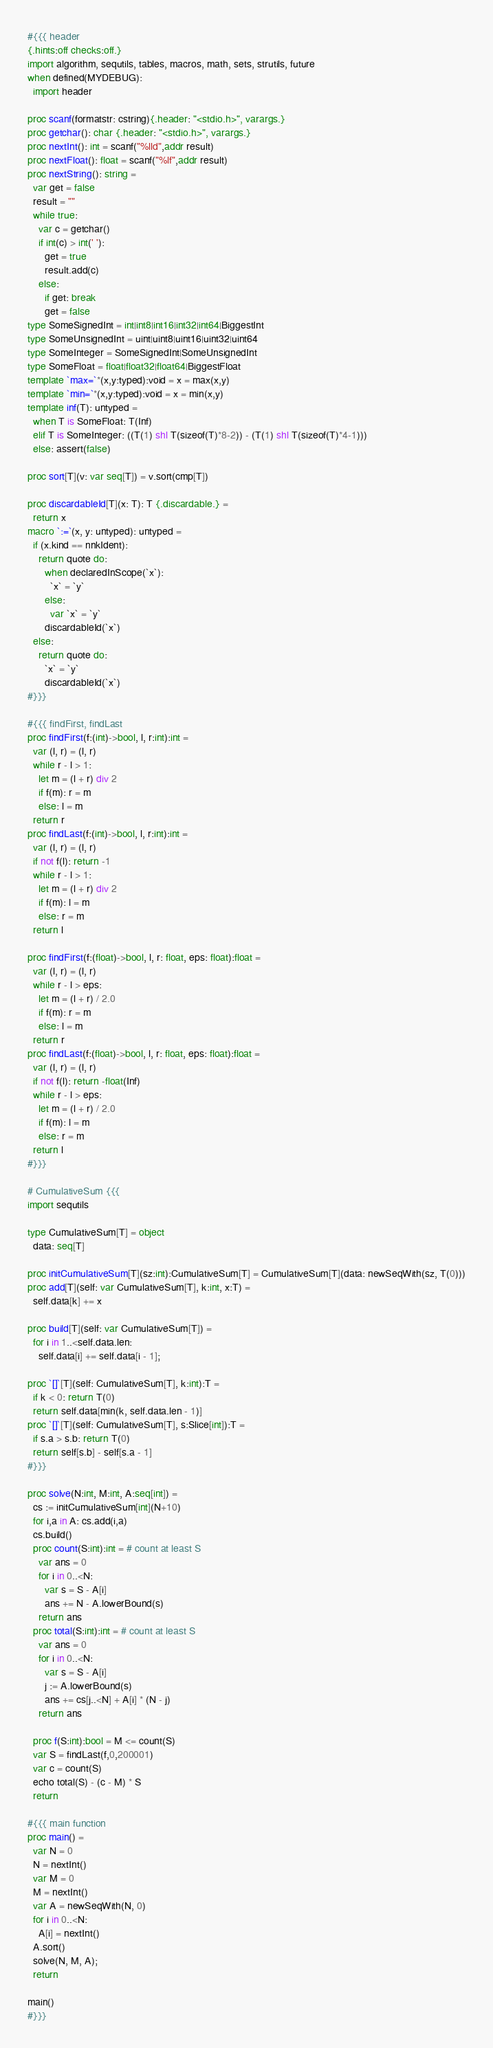<code> <loc_0><loc_0><loc_500><loc_500><_Nim_>#{{{ header
{.hints:off checks:off.}
import algorithm, sequtils, tables, macros, math, sets, strutils, future
when defined(MYDEBUG):
  import header

proc scanf(formatstr: cstring){.header: "<stdio.h>", varargs.}
proc getchar(): char {.header: "<stdio.h>", varargs.}
proc nextInt(): int = scanf("%lld",addr result)
proc nextFloat(): float = scanf("%lf",addr result)
proc nextString(): string =
  var get = false
  result = ""
  while true:
    var c = getchar()
    if int(c) > int(' '):
      get = true
      result.add(c)
    else:
      if get: break
      get = false
type SomeSignedInt = int|int8|int16|int32|int64|BiggestInt
type SomeUnsignedInt = uint|uint8|uint16|uint32|uint64
type SomeInteger = SomeSignedInt|SomeUnsignedInt
type SomeFloat = float|float32|float64|BiggestFloat
template `max=`*(x,y:typed):void = x = max(x,y)
template `min=`*(x,y:typed):void = x = min(x,y)
template inf(T): untyped = 
  when T is SomeFloat: T(Inf)
  elif T is SomeInteger: ((T(1) shl T(sizeof(T)*8-2)) - (T(1) shl T(sizeof(T)*4-1)))
  else: assert(false)

proc sort[T](v: var seq[T]) = v.sort(cmp[T])

proc discardableId[T](x: T): T {.discardable.} =
  return x
macro `:=`(x, y: untyped): untyped =
  if (x.kind == nnkIdent):
    return quote do:
      when declaredInScope(`x`):
        `x` = `y`
      else:
        var `x` = `y`
      discardableId(`x`)
  else:
    return quote do:
      `x` = `y`
      discardableId(`x`)
#}}}

#{{{ findFirst, findLast
proc findFirst(f:(int)->bool, l, r:int):int =
  var (l, r) = (l, r)
  while r - l > 1:
    let m = (l + r) div 2
    if f(m): r = m
    else: l = m
  return r
proc findLast(f:(int)->bool, l, r:int):int =
  var (l, r) = (l, r)
  if not f(l): return -1
  while r - l > 1:
    let m = (l + r) div 2
    if f(m): l = m
    else: r = m
  return l

proc findFirst(f:(float)->bool, l, r: float, eps: float):float =
  var (l, r) = (l, r)
  while r - l > eps:
    let m = (l + r) / 2.0
    if f(m): r = m
    else: l = m
  return r
proc findLast(f:(float)->bool, l, r: float, eps: float):float =
  var (l, r) = (l, r)
  if not f(l): return -float(Inf)
  while r - l > eps:
    let m = (l + r) / 2.0
    if f(m): l = m
    else: r = m
  return l
#}}}

# CumulativeSum {{{
import sequtils

type CumulativeSum[T] = object
  data: seq[T]

proc initCumulativeSum[T](sz:int):CumulativeSum[T] = CumulativeSum[T](data: newSeqWith(sz, T(0)))
proc add[T](self: var CumulativeSum[T], k:int, x:T) =
  self.data[k] += x

proc build[T](self: var CumulativeSum[T]) =
  for i in 1..<self.data.len:
    self.data[i] += self.data[i - 1];

proc `[]`[T](self: CumulativeSum[T], k:int):T =
  if k < 0: return T(0)
  return self.data[min(k, self.data.len - 1)]
proc `[]`[T](self: CumulativeSum[T], s:Slice[int]):T =
  if s.a > s.b: return T(0)
  return self[s.b] - self[s.a - 1]
#}}}

proc solve(N:int, M:int, A:seq[int]) =
  cs := initCumulativeSum[int](N+10)
  for i,a in A: cs.add(i,a)
  cs.build()
  proc count(S:int):int = # count at least S
    var ans = 0
    for i in 0..<N:
      var s = S - A[i]
      ans += N - A.lowerBound(s)
    return ans
  proc total(S:int):int = # count at least S
    var ans = 0
    for i in 0..<N:
      var s = S - A[i]
      j := A.lowerBound(s)
      ans += cs[j..<N] + A[i] * (N - j)
    return ans

  proc f(S:int):bool = M <= count(S)
  var S = findLast(f,0,200001)
  var c = count(S)
  echo total(S) - (c - M) * S
  return

#{{{ main function
proc main() =
  var N = 0
  N = nextInt()
  var M = 0
  M = nextInt()
  var A = newSeqWith(N, 0)
  for i in 0..<N:
    A[i] = nextInt()
  A.sort()
  solve(N, M, A);
  return

main()
#}}}
</code> 